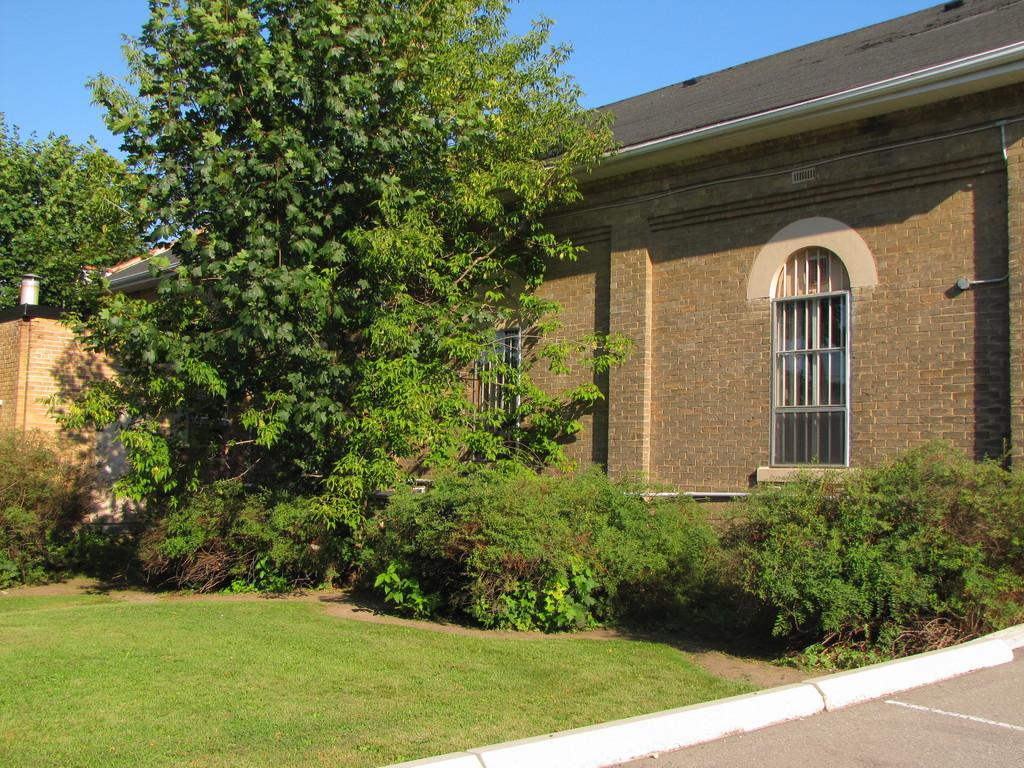What type of structure is present in the image? There is a house in the image. Can you describe any features of the house? There is a light attached to the wall of the house. What type of vegetation can be seen in the image? There are trees and grass in the image. What is visible in the background of the image? The sky is visible in the image. What type of nut is being used as a door handle in the image? There is no nut being used as a door handle in the image; the door handle is not mentioned in the provided facts. Can you tell me how many animals are sleeping in the image? There are no animals present in the image, so it is not possible to determine how many might be sleeping. 